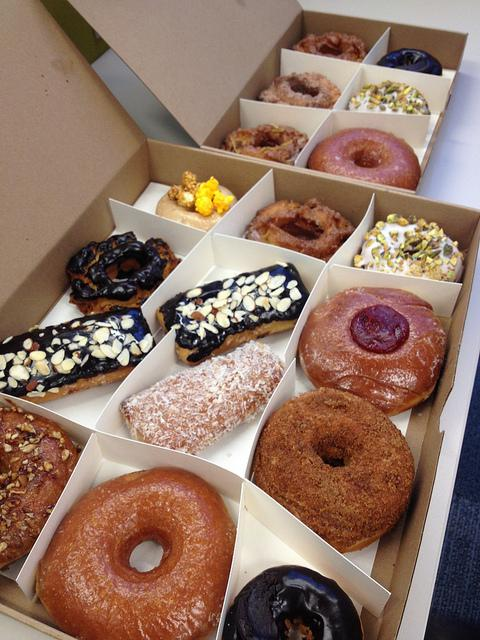What is the most common topping on the frosting? chocolate 